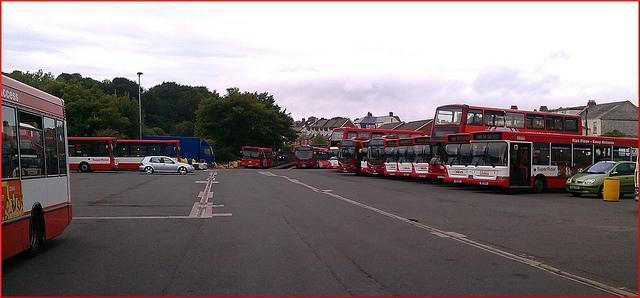How many cars are parked?
Give a very brief answer. 2. How many buses are in the picture?
Give a very brief answer. 4. How many people are there?
Give a very brief answer. 0. 